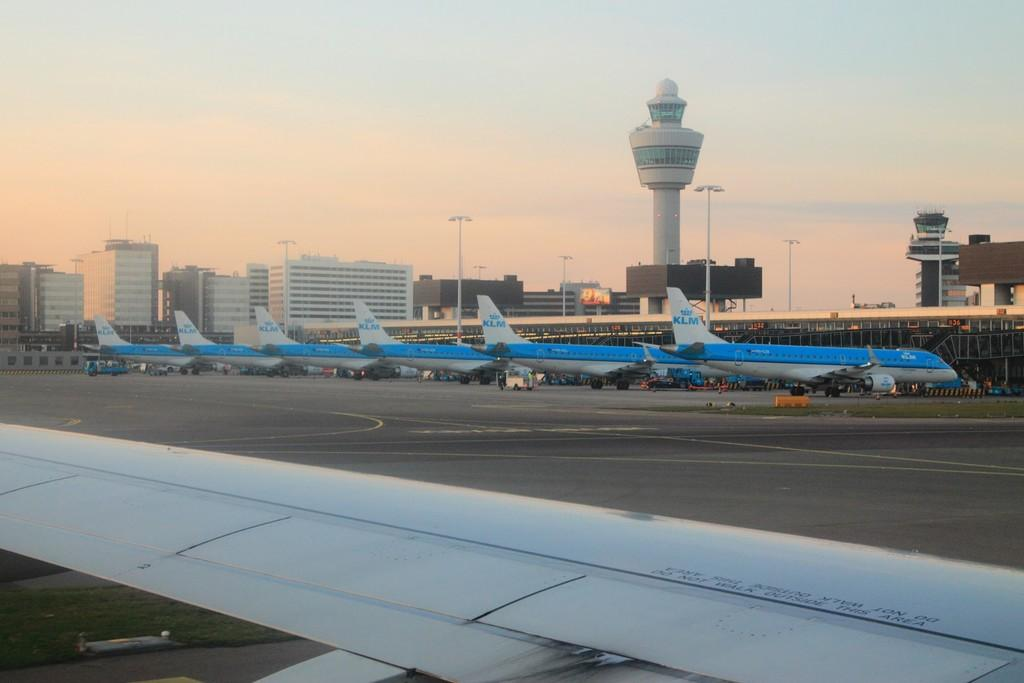What type of location is shown in the image? The image depicts an airport. What can be seen in the image that is related to air travel? There are aeroplanes in the image. What structures are visible in the background of the image? There are buildings, poles, and towers in the background of the image. What is at the bottom of the image? There is a road at the bottom of the image. What part of the natural environment is visible in the image? The sky is visible at the top of the image. What type of ghost is haunting the airport in the image? There is no ghost present in the image; it depicts an airport with aeroplanes, buildings, poles, and towers. Who is the manager of the airport in the image? The image does not provide information about the airport's management, so it cannot be determined from the image. 